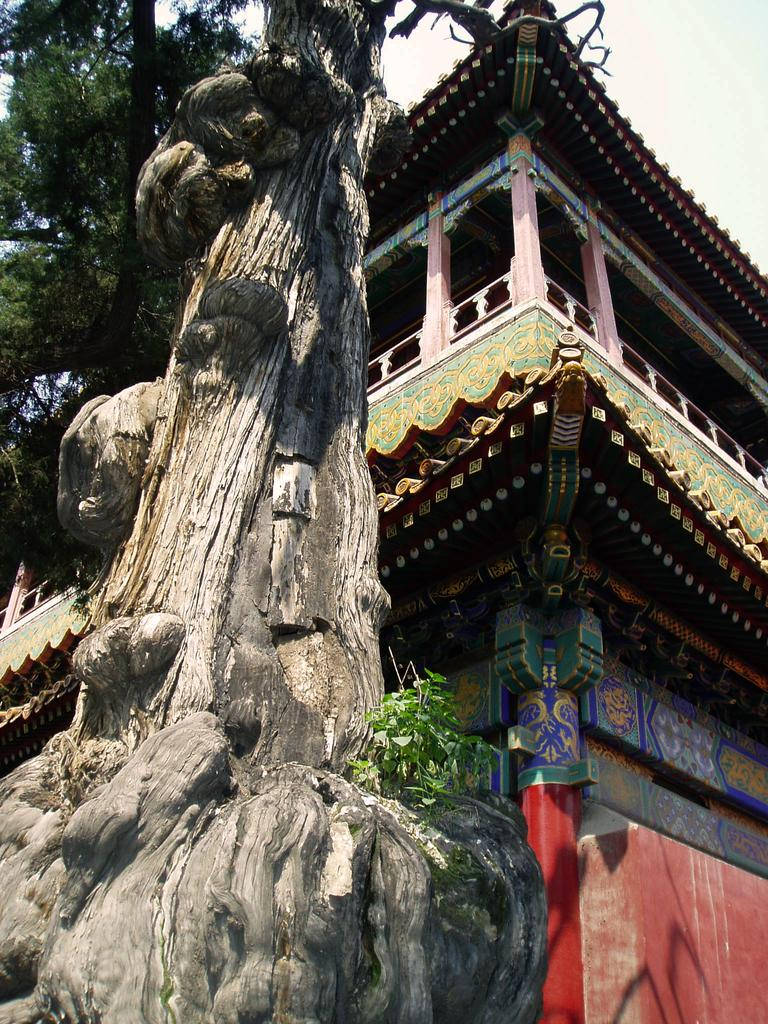What type of building is in the image? There is a multicolored building in the image. What can be seen in the background of the image? There are trees and the sky visible in the background of the image. What color are the trees? The trees are green. What is the color of the sky in the image? The sky is white in the image. How does the building control the war in the image? There is no war or control mentioned in the image; it only features a multicolored building, trees, and the sky. 